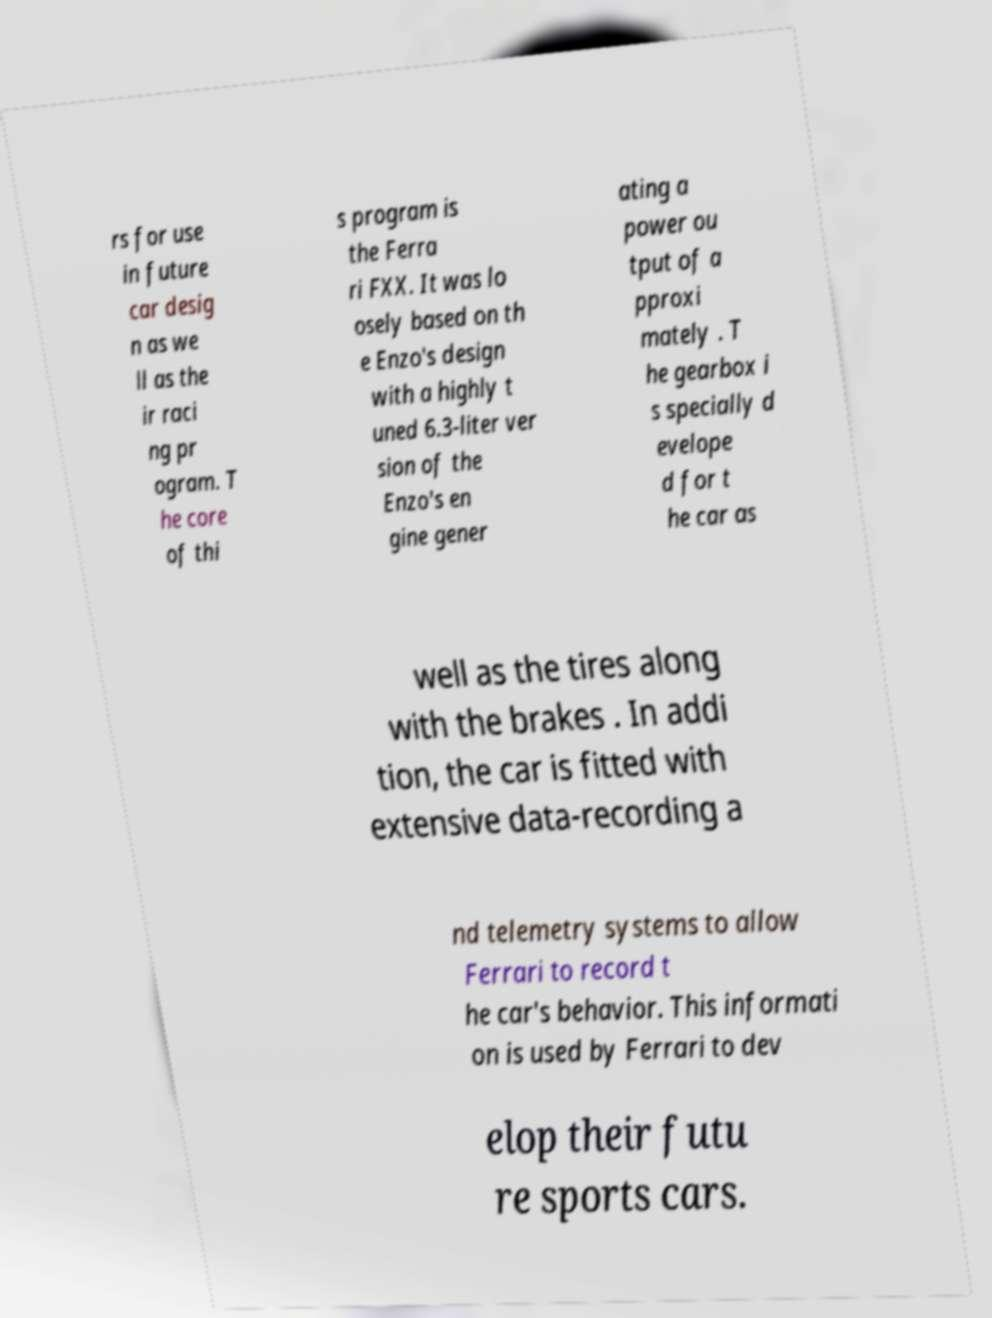There's text embedded in this image that I need extracted. Can you transcribe it verbatim? rs for use in future car desig n as we ll as the ir raci ng pr ogram. T he core of thi s program is the Ferra ri FXX. It was lo osely based on th e Enzo's design with a highly t uned 6.3-liter ver sion of the Enzo's en gine gener ating a power ou tput of a pproxi mately . T he gearbox i s specially d evelope d for t he car as well as the tires along with the brakes . In addi tion, the car is fitted with extensive data-recording a nd telemetry systems to allow Ferrari to record t he car's behavior. This informati on is used by Ferrari to dev elop their futu re sports cars. 